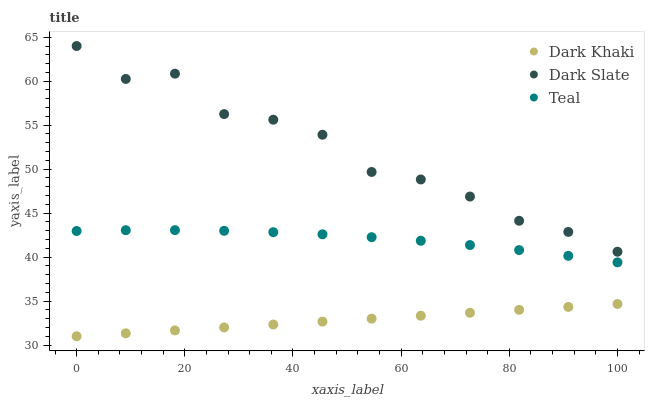Does Dark Khaki have the minimum area under the curve?
Answer yes or no. Yes. Does Dark Slate have the maximum area under the curve?
Answer yes or no. Yes. Does Teal have the minimum area under the curve?
Answer yes or no. No. Does Teal have the maximum area under the curve?
Answer yes or no. No. Is Dark Khaki the smoothest?
Answer yes or no. Yes. Is Dark Slate the roughest?
Answer yes or no. Yes. Is Teal the smoothest?
Answer yes or no. No. Is Teal the roughest?
Answer yes or no. No. Does Dark Khaki have the lowest value?
Answer yes or no. Yes. Does Teal have the lowest value?
Answer yes or no. No. Does Dark Slate have the highest value?
Answer yes or no. Yes. Does Teal have the highest value?
Answer yes or no. No. Is Teal less than Dark Slate?
Answer yes or no. Yes. Is Dark Slate greater than Dark Khaki?
Answer yes or no. Yes. Does Teal intersect Dark Slate?
Answer yes or no. No. 